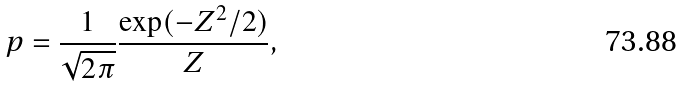<formula> <loc_0><loc_0><loc_500><loc_500>p = \frac { 1 } { \sqrt { 2 \pi } } \frac { \exp ( - Z ^ { 2 } / 2 ) } { Z } ,</formula> 